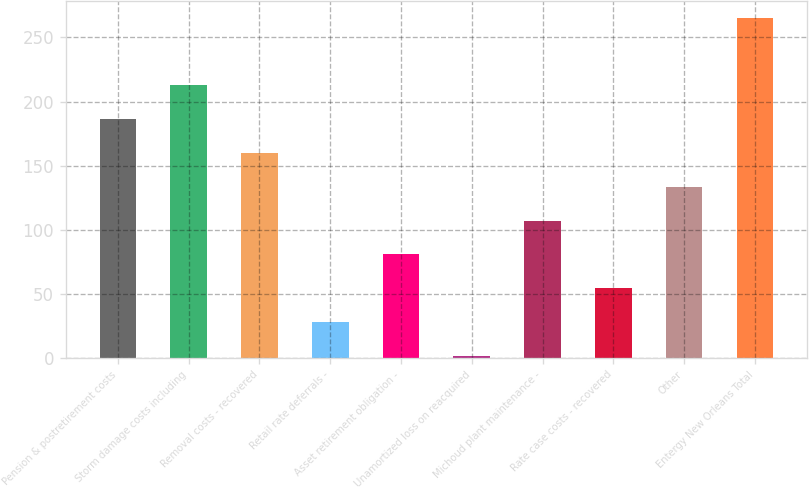Convert chart. <chart><loc_0><loc_0><loc_500><loc_500><bar_chart><fcel>Pension & postretirement costs<fcel>Storm damage costs including<fcel>Removal costs - recovered<fcel>Retail rate deferrals -<fcel>Asset retirement obligation -<fcel>Unamortized loss on reacquired<fcel>Michoud plant maintenance -<fcel>Rate case costs - recovered<fcel>Other<fcel>Entergy New Orleans Total<nl><fcel>186.19<fcel>212.56<fcel>159.82<fcel>27.97<fcel>80.71<fcel>1.6<fcel>107.08<fcel>54.34<fcel>133.45<fcel>265.3<nl></chart> 